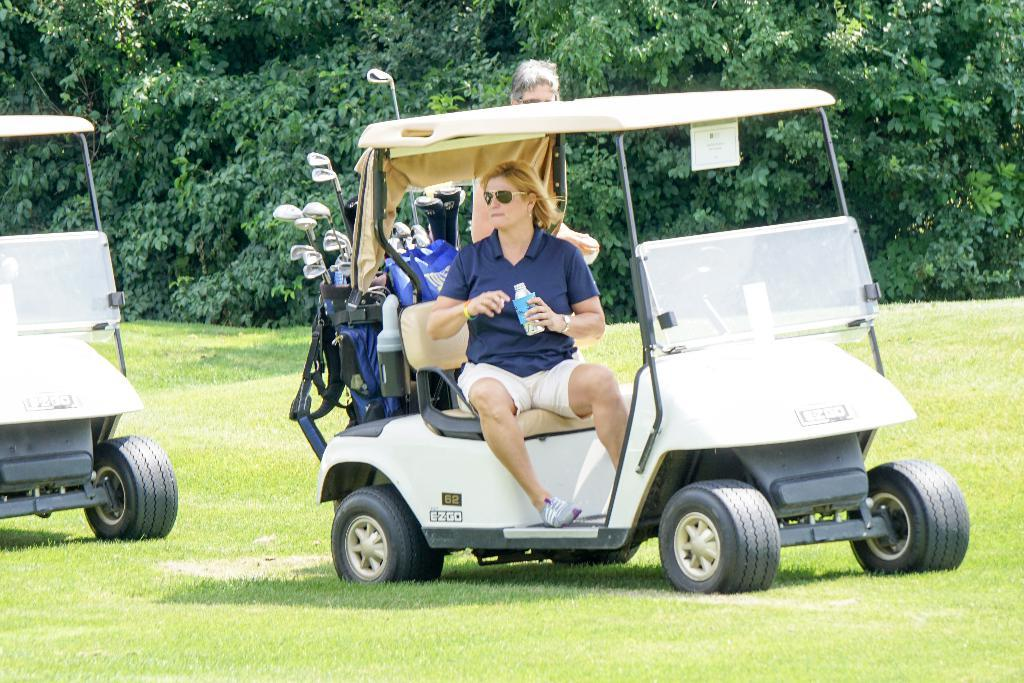How many people are in the image? There are two people in the image. What can be seen inside the vehicle with the people? There are many golf-sticks in the vehicle. What is the position of the other vehicle in relation to the first vehicle? The other vehicle is to the left. Where are the vehicles located? The vehicles are on the ground. What type of environment is visible in the background of the image? There are many trees in the background of the image. What type of cream is being used to make the people comfortable in the image? There is no cream or comfort-related activity present in the image. What level of difficulty can be seen in the golf-sticks in the image? The image does not provide information about the difficulty level of the golf-sticks. 